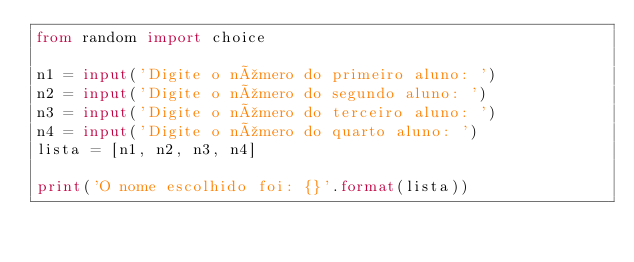<code> <loc_0><loc_0><loc_500><loc_500><_Python_>from random import choice

n1 = input('Digite o número do primeiro aluno: ')
n2 = input('Digite o número do segundo aluno: ')
n3 = input('Digite o número do terceiro aluno: ')
n4 = input('Digite o número do quarto aluno: ')
lista = [n1, n2, n3, n4]

print('O nome escolhido foi: {}'.format(lista))</code> 